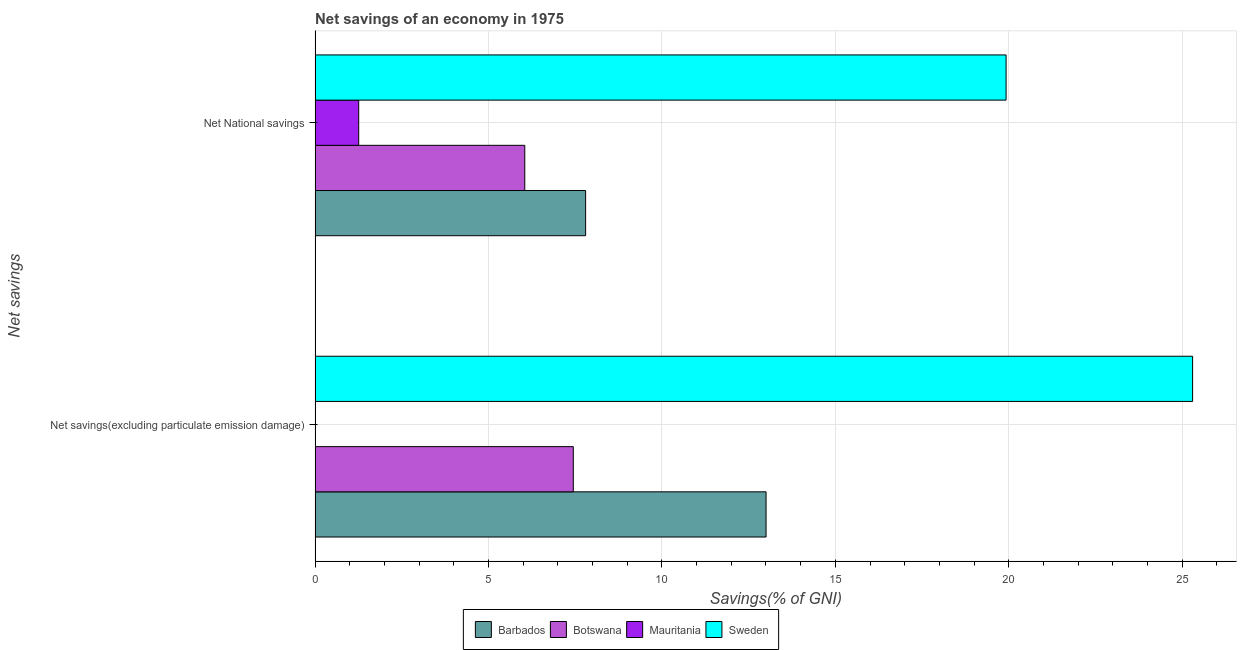How many groups of bars are there?
Offer a very short reply. 2. Are the number of bars per tick equal to the number of legend labels?
Your answer should be compact. No. How many bars are there on the 2nd tick from the top?
Make the answer very short. 3. How many bars are there on the 2nd tick from the bottom?
Provide a short and direct response. 4. What is the label of the 2nd group of bars from the top?
Make the answer very short. Net savings(excluding particulate emission damage). What is the net savings(excluding particulate emission damage) in Barbados?
Your answer should be compact. 13. Across all countries, what is the maximum net national savings?
Provide a succinct answer. 19.92. Across all countries, what is the minimum net national savings?
Give a very brief answer. 1.26. In which country was the net savings(excluding particulate emission damage) maximum?
Ensure brevity in your answer.  Sweden. What is the total net national savings in the graph?
Offer a terse response. 35.03. What is the difference between the net national savings in Mauritania and that in Barbados?
Ensure brevity in your answer.  -6.54. What is the difference between the net savings(excluding particulate emission damage) in Barbados and the net national savings in Mauritania?
Offer a terse response. 11.75. What is the average net national savings per country?
Keep it short and to the point. 8.76. What is the difference between the net savings(excluding particulate emission damage) and net national savings in Barbados?
Offer a terse response. 5.2. What is the ratio of the net national savings in Botswana to that in Mauritania?
Your answer should be very brief. 4.81. Is the net national savings in Mauritania less than that in Barbados?
Make the answer very short. Yes. How many bars are there?
Keep it short and to the point. 7. Are all the bars in the graph horizontal?
Your response must be concise. Yes. How many countries are there in the graph?
Give a very brief answer. 4. What is the difference between two consecutive major ticks on the X-axis?
Provide a succinct answer. 5. Are the values on the major ticks of X-axis written in scientific E-notation?
Offer a very short reply. No. Does the graph contain any zero values?
Ensure brevity in your answer.  Yes. How are the legend labels stacked?
Ensure brevity in your answer.  Horizontal. What is the title of the graph?
Keep it short and to the point. Net savings of an economy in 1975. Does "Faeroe Islands" appear as one of the legend labels in the graph?
Give a very brief answer. No. What is the label or title of the X-axis?
Your answer should be compact. Savings(% of GNI). What is the label or title of the Y-axis?
Your answer should be compact. Net savings. What is the Savings(% of GNI) in Barbados in Net savings(excluding particulate emission damage)?
Provide a succinct answer. 13. What is the Savings(% of GNI) of Botswana in Net savings(excluding particulate emission damage)?
Your response must be concise. 7.44. What is the Savings(% of GNI) in Sweden in Net savings(excluding particulate emission damage)?
Provide a succinct answer. 25.3. What is the Savings(% of GNI) of Barbados in Net National savings?
Offer a terse response. 7.8. What is the Savings(% of GNI) in Botswana in Net National savings?
Your response must be concise. 6.05. What is the Savings(% of GNI) in Mauritania in Net National savings?
Provide a succinct answer. 1.26. What is the Savings(% of GNI) in Sweden in Net National savings?
Your response must be concise. 19.92. Across all Net savings, what is the maximum Savings(% of GNI) in Barbados?
Make the answer very short. 13. Across all Net savings, what is the maximum Savings(% of GNI) in Botswana?
Provide a short and direct response. 7.44. Across all Net savings, what is the maximum Savings(% of GNI) of Mauritania?
Your answer should be very brief. 1.26. Across all Net savings, what is the maximum Savings(% of GNI) in Sweden?
Give a very brief answer. 25.3. Across all Net savings, what is the minimum Savings(% of GNI) in Barbados?
Offer a terse response. 7.8. Across all Net savings, what is the minimum Savings(% of GNI) in Botswana?
Your response must be concise. 6.05. Across all Net savings, what is the minimum Savings(% of GNI) of Sweden?
Your answer should be compact. 19.92. What is the total Savings(% of GNI) in Barbados in the graph?
Provide a short and direct response. 20.8. What is the total Savings(% of GNI) in Botswana in the graph?
Offer a very short reply. 13.49. What is the total Savings(% of GNI) of Mauritania in the graph?
Keep it short and to the point. 1.26. What is the total Savings(% of GNI) in Sweden in the graph?
Provide a short and direct response. 45.22. What is the difference between the Savings(% of GNI) of Barbados in Net savings(excluding particulate emission damage) and that in Net National savings?
Your answer should be very brief. 5.2. What is the difference between the Savings(% of GNI) in Botswana in Net savings(excluding particulate emission damage) and that in Net National savings?
Your answer should be compact. 1.4. What is the difference between the Savings(% of GNI) in Sweden in Net savings(excluding particulate emission damage) and that in Net National savings?
Provide a short and direct response. 5.38. What is the difference between the Savings(% of GNI) in Barbados in Net savings(excluding particulate emission damage) and the Savings(% of GNI) in Botswana in Net National savings?
Provide a succinct answer. 6.96. What is the difference between the Savings(% of GNI) of Barbados in Net savings(excluding particulate emission damage) and the Savings(% of GNI) of Mauritania in Net National savings?
Your response must be concise. 11.75. What is the difference between the Savings(% of GNI) of Barbados in Net savings(excluding particulate emission damage) and the Savings(% of GNI) of Sweden in Net National savings?
Your answer should be very brief. -6.92. What is the difference between the Savings(% of GNI) of Botswana in Net savings(excluding particulate emission damage) and the Savings(% of GNI) of Mauritania in Net National savings?
Your answer should be compact. 6.19. What is the difference between the Savings(% of GNI) in Botswana in Net savings(excluding particulate emission damage) and the Savings(% of GNI) in Sweden in Net National savings?
Your response must be concise. -12.48. What is the average Savings(% of GNI) in Barbados per Net savings?
Your answer should be compact. 10.4. What is the average Savings(% of GNI) in Botswana per Net savings?
Give a very brief answer. 6.75. What is the average Savings(% of GNI) in Mauritania per Net savings?
Provide a short and direct response. 0.63. What is the average Savings(% of GNI) in Sweden per Net savings?
Ensure brevity in your answer.  22.61. What is the difference between the Savings(% of GNI) of Barbados and Savings(% of GNI) of Botswana in Net savings(excluding particulate emission damage)?
Your response must be concise. 5.56. What is the difference between the Savings(% of GNI) in Barbados and Savings(% of GNI) in Sweden in Net savings(excluding particulate emission damage)?
Your response must be concise. -12.3. What is the difference between the Savings(% of GNI) in Botswana and Savings(% of GNI) in Sweden in Net savings(excluding particulate emission damage)?
Make the answer very short. -17.86. What is the difference between the Savings(% of GNI) of Barbados and Savings(% of GNI) of Botswana in Net National savings?
Offer a very short reply. 1.75. What is the difference between the Savings(% of GNI) of Barbados and Savings(% of GNI) of Mauritania in Net National savings?
Offer a terse response. 6.54. What is the difference between the Savings(% of GNI) of Barbados and Savings(% of GNI) of Sweden in Net National savings?
Your answer should be compact. -12.12. What is the difference between the Savings(% of GNI) in Botswana and Savings(% of GNI) in Mauritania in Net National savings?
Offer a very short reply. 4.79. What is the difference between the Savings(% of GNI) in Botswana and Savings(% of GNI) in Sweden in Net National savings?
Provide a short and direct response. -13.88. What is the difference between the Savings(% of GNI) in Mauritania and Savings(% of GNI) in Sweden in Net National savings?
Provide a succinct answer. -18.67. What is the ratio of the Savings(% of GNI) in Barbados in Net savings(excluding particulate emission damage) to that in Net National savings?
Give a very brief answer. 1.67. What is the ratio of the Savings(% of GNI) of Botswana in Net savings(excluding particulate emission damage) to that in Net National savings?
Provide a short and direct response. 1.23. What is the ratio of the Savings(% of GNI) of Sweden in Net savings(excluding particulate emission damage) to that in Net National savings?
Keep it short and to the point. 1.27. What is the difference between the highest and the second highest Savings(% of GNI) of Barbados?
Your answer should be compact. 5.2. What is the difference between the highest and the second highest Savings(% of GNI) in Botswana?
Offer a terse response. 1.4. What is the difference between the highest and the second highest Savings(% of GNI) in Sweden?
Provide a short and direct response. 5.38. What is the difference between the highest and the lowest Savings(% of GNI) of Barbados?
Ensure brevity in your answer.  5.2. What is the difference between the highest and the lowest Savings(% of GNI) in Botswana?
Offer a very short reply. 1.4. What is the difference between the highest and the lowest Savings(% of GNI) in Mauritania?
Make the answer very short. 1.26. What is the difference between the highest and the lowest Savings(% of GNI) in Sweden?
Your response must be concise. 5.38. 